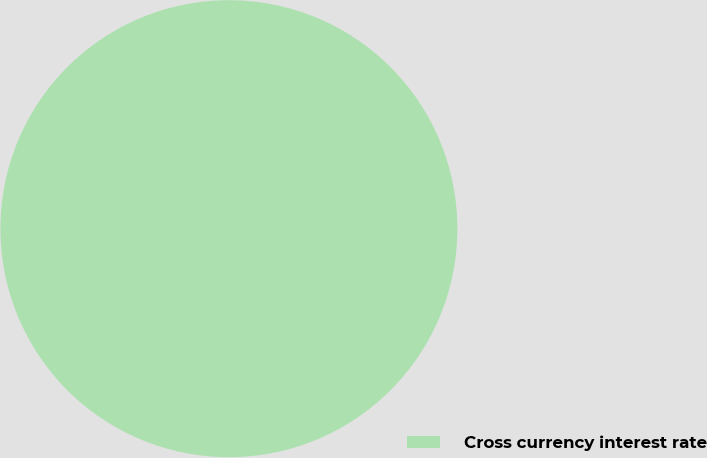Convert chart. <chart><loc_0><loc_0><loc_500><loc_500><pie_chart><fcel>Cross currency interest rate<nl><fcel>100.0%<nl></chart> 